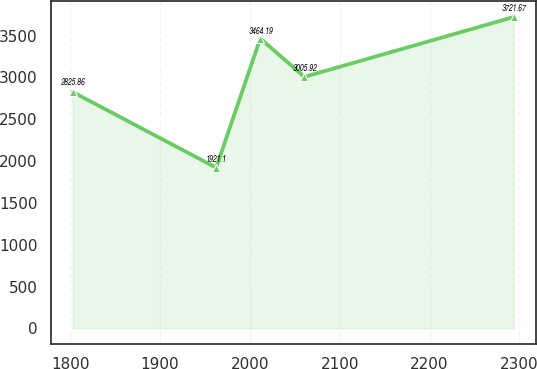Convert chart. <chart><loc_0><loc_0><loc_500><loc_500><line_chart><ecel><fcel>Unnamed: 1<nl><fcel>1802.55<fcel>2825.86<nl><fcel>1962.41<fcel>1921.1<nl><fcel>2011.54<fcel>3464.19<nl><fcel>2060.67<fcel>3005.92<nl><fcel>2293.83<fcel>3721.67<nl></chart> 